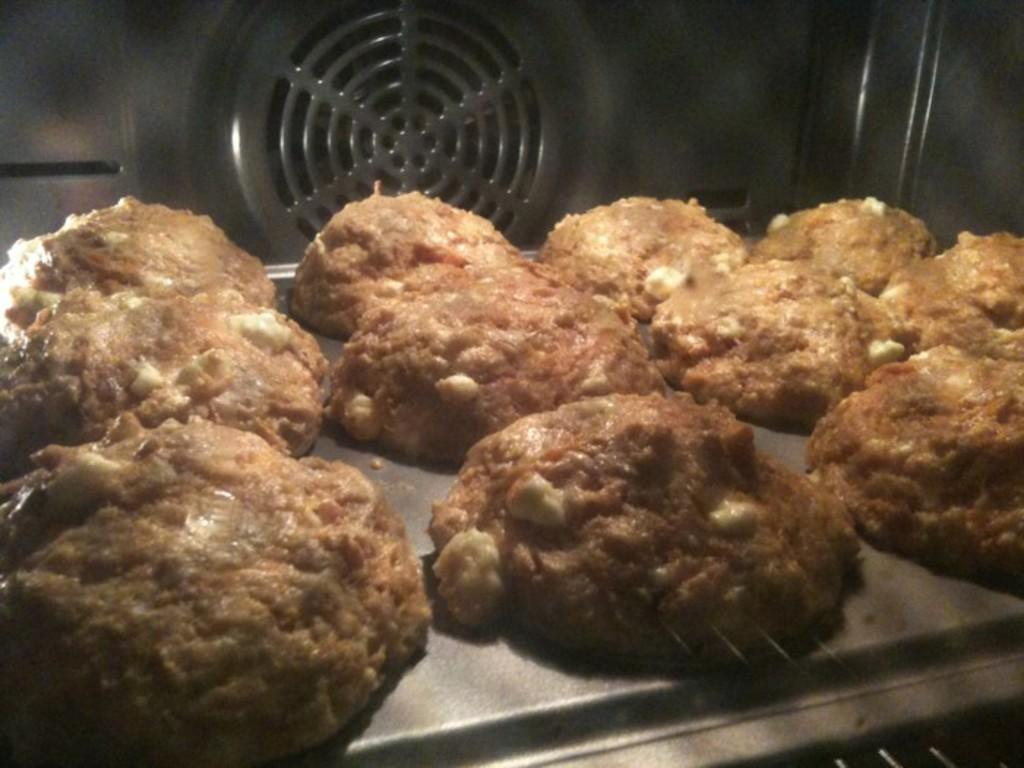What is placed in the oven in the image? There are cookies placed in the oven in the image. What might be the purpose of placing cookies in the oven? The purpose of placing cookies in the oven is to bake them. What is the current state of the cookies in the image? The cookies are in the oven, so they are likely being heated or cooked. What type of rifle can be seen leaning against the oven in the image? There is no rifle present in the image; it only shows cookies placed in the oven. 